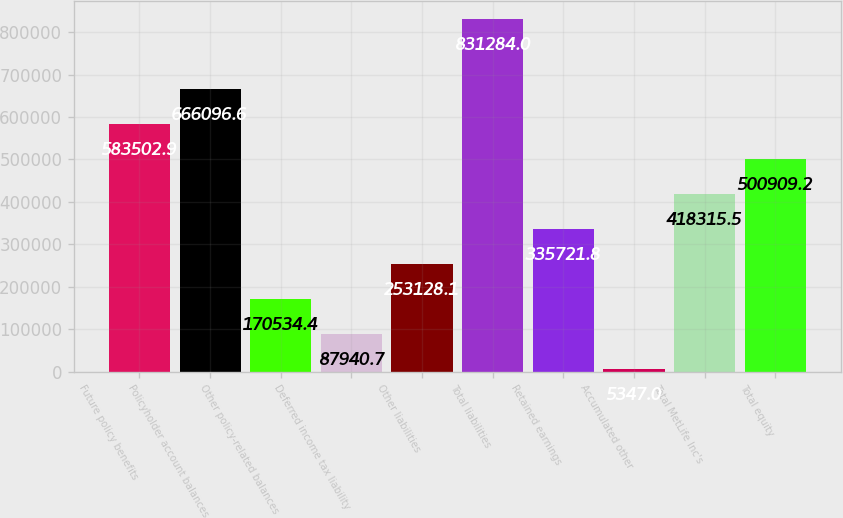<chart> <loc_0><loc_0><loc_500><loc_500><bar_chart><fcel>Future policy benefits<fcel>Policyholder account balances<fcel>Other policy-related balances<fcel>Deferred income tax liability<fcel>Other liabilities<fcel>Total liabilities<fcel>Retained earnings<fcel>Accumulated other<fcel>Total MetLife Inc's<fcel>Total equity<nl><fcel>583503<fcel>666097<fcel>170534<fcel>87940.7<fcel>253128<fcel>831284<fcel>335722<fcel>5347<fcel>418316<fcel>500909<nl></chart> 